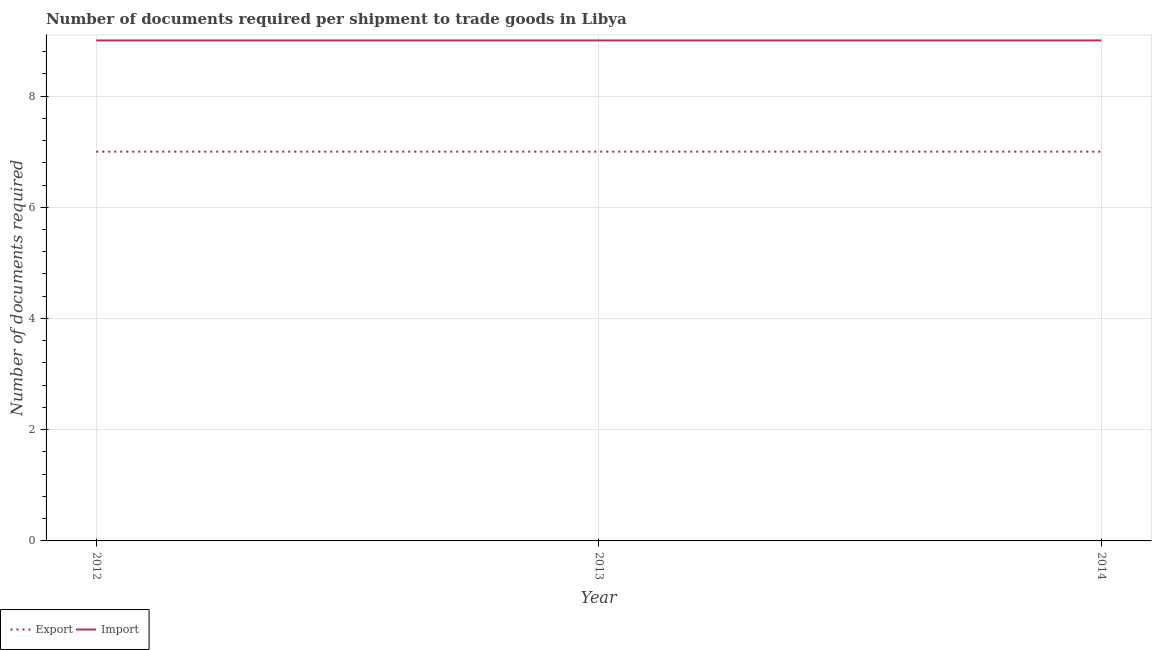How many different coloured lines are there?
Ensure brevity in your answer.  2. What is the number of documents required to export goods in 2014?
Offer a terse response. 7. Across all years, what is the maximum number of documents required to import goods?
Your response must be concise. 9. Across all years, what is the minimum number of documents required to export goods?
Offer a terse response. 7. In which year was the number of documents required to import goods maximum?
Offer a terse response. 2012. In which year was the number of documents required to export goods minimum?
Your answer should be very brief. 2012. What is the total number of documents required to import goods in the graph?
Provide a short and direct response. 27. What is the difference between the number of documents required to export goods in 2014 and the number of documents required to import goods in 2013?
Your response must be concise. -2. What is the average number of documents required to export goods per year?
Your answer should be very brief. 7. In the year 2012, what is the difference between the number of documents required to import goods and number of documents required to export goods?
Your answer should be compact. 2. What is the difference between the highest and the second highest number of documents required to export goods?
Your answer should be very brief. 0. In how many years, is the number of documents required to export goods greater than the average number of documents required to export goods taken over all years?
Make the answer very short. 0. Is the sum of the number of documents required to export goods in 2012 and 2014 greater than the maximum number of documents required to import goods across all years?
Keep it short and to the point. Yes. Does the number of documents required to import goods monotonically increase over the years?
Your answer should be compact. No. How many lines are there?
Keep it short and to the point. 2. What is the difference between two consecutive major ticks on the Y-axis?
Ensure brevity in your answer.  2. Are the values on the major ticks of Y-axis written in scientific E-notation?
Your response must be concise. No. Where does the legend appear in the graph?
Your answer should be compact. Bottom left. How are the legend labels stacked?
Ensure brevity in your answer.  Horizontal. What is the title of the graph?
Provide a succinct answer. Number of documents required per shipment to trade goods in Libya. What is the label or title of the Y-axis?
Your response must be concise. Number of documents required. What is the Number of documents required in Import in 2012?
Offer a very short reply. 9. What is the Number of documents required of Export in 2014?
Provide a short and direct response. 7. What is the Number of documents required in Import in 2014?
Provide a succinct answer. 9. Across all years, what is the maximum Number of documents required in Export?
Your response must be concise. 7. Across all years, what is the maximum Number of documents required in Import?
Provide a succinct answer. 9. What is the total Number of documents required in Export in the graph?
Keep it short and to the point. 21. What is the difference between the Number of documents required of Export in 2012 and that in 2014?
Give a very brief answer. 0. What is the difference between the Number of documents required of Import in 2012 and that in 2014?
Offer a terse response. 0. What is the average Number of documents required in Import per year?
Ensure brevity in your answer.  9. In the year 2012, what is the difference between the Number of documents required in Export and Number of documents required in Import?
Make the answer very short. -2. What is the ratio of the Number of documents required in Import in 2012 to that in 2013?
Make the answer very short. 1. What is the ratio of the Number of documents required in Import in 2013 to that in 2014?
Provide a succinct answer. 1. What is the difference between the highest and the second highest Number of documents required in Export?
Keep it short and to the point. 0. What is the difference between the highest and the lowest Number of documents required in Export?
Give a very brief answer. 0. What is the difference between the highest and the lowest Number of documents required in Import?
Your answer should be very brief. 0. 